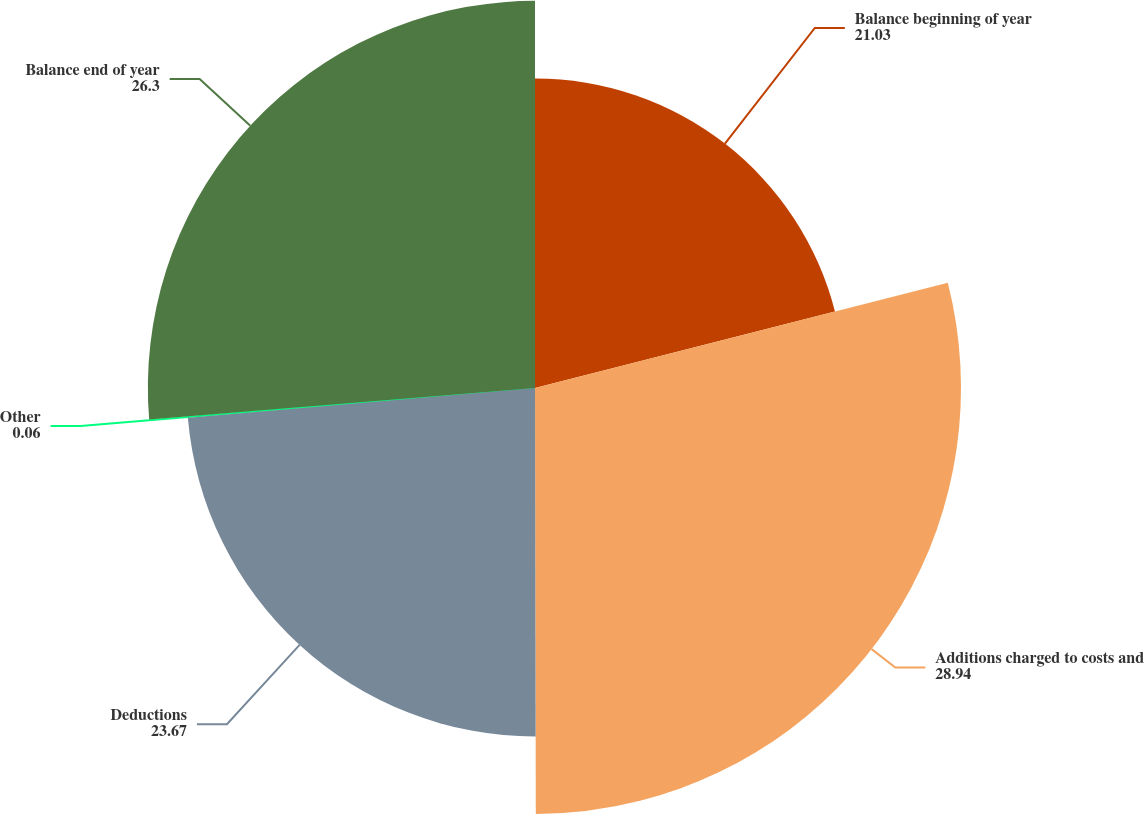Convert chart. <chart><loc_0><loc_0><loc_500><loc_500><pie_chart><fcel>Balance beginning of year<fcel>Additions charged to costs and<fcel>Deductions<fcel>Other<fcel>Balance end of year<nl><fcel>21.03%<fcel>28.94%<fcel>23.67%<fcel>0.06%<fcel>26.3%<nl></chart> 